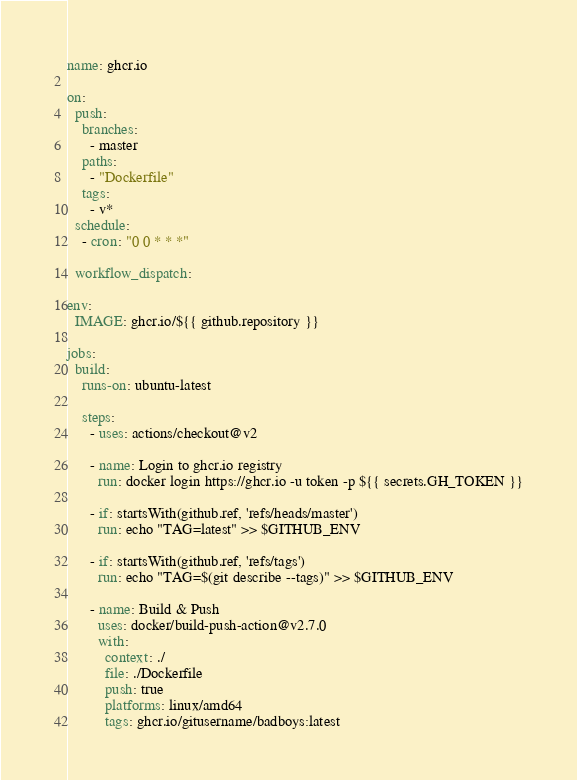<code> <loc_0><loc_0><loc_500><loc_500><_YAML_>name: ghcr.io

on:
  push:
    branches:
      - master
    paths:
      - "Dockerfile"     
    tags:
      - v*
  schedule:
    - cron: "0 0 * * *"
    
  workflow_dispatch:    

env:
  IMAGE: ghcr.io/${{ github.repository }}

jobs:
  build:
    runs-on: ubuntu-latest

    steps:
      - uses: actions/checkout@v2

      - name: Login to ghcr.io registry
        run: docker login https://ghcr.io -u token -p ${{ secrets.GH_TOKEN }}

      - if: startsWith(github.ref, 'refs/heads/master')
        run: echo "TAG=latest" >> $GITHUB_ENV

      - if: startsWith(github.ref, 'refs/tags')
        run: echo "TAG=$(git describe --tags)" >> $GITHUB_ENV

      - name: Build & Push
        uses: docker/build-push-action@v2.7.0
        with:
          context: ./
          file: ./Dockerfile
          push: true
          platforms: linux/amd64
          tags: ghcr.io/gitusername/badboys:latest
</code> 